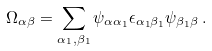Convert formula to latex. <formula><loc_0><loc_0><loc_500><loc_500>\Omega _ { \alpha \beta } = \sum _ { \alpha _ { 1 } , \beta _ { 1 } } \psi _ { \alpha \alpha _ { 1 } } \epsilon _ { \alpha _ { 1 } \beta _ { 1 } } \psi _ { \beta _ { 1 } \beta } \, .</formula> 